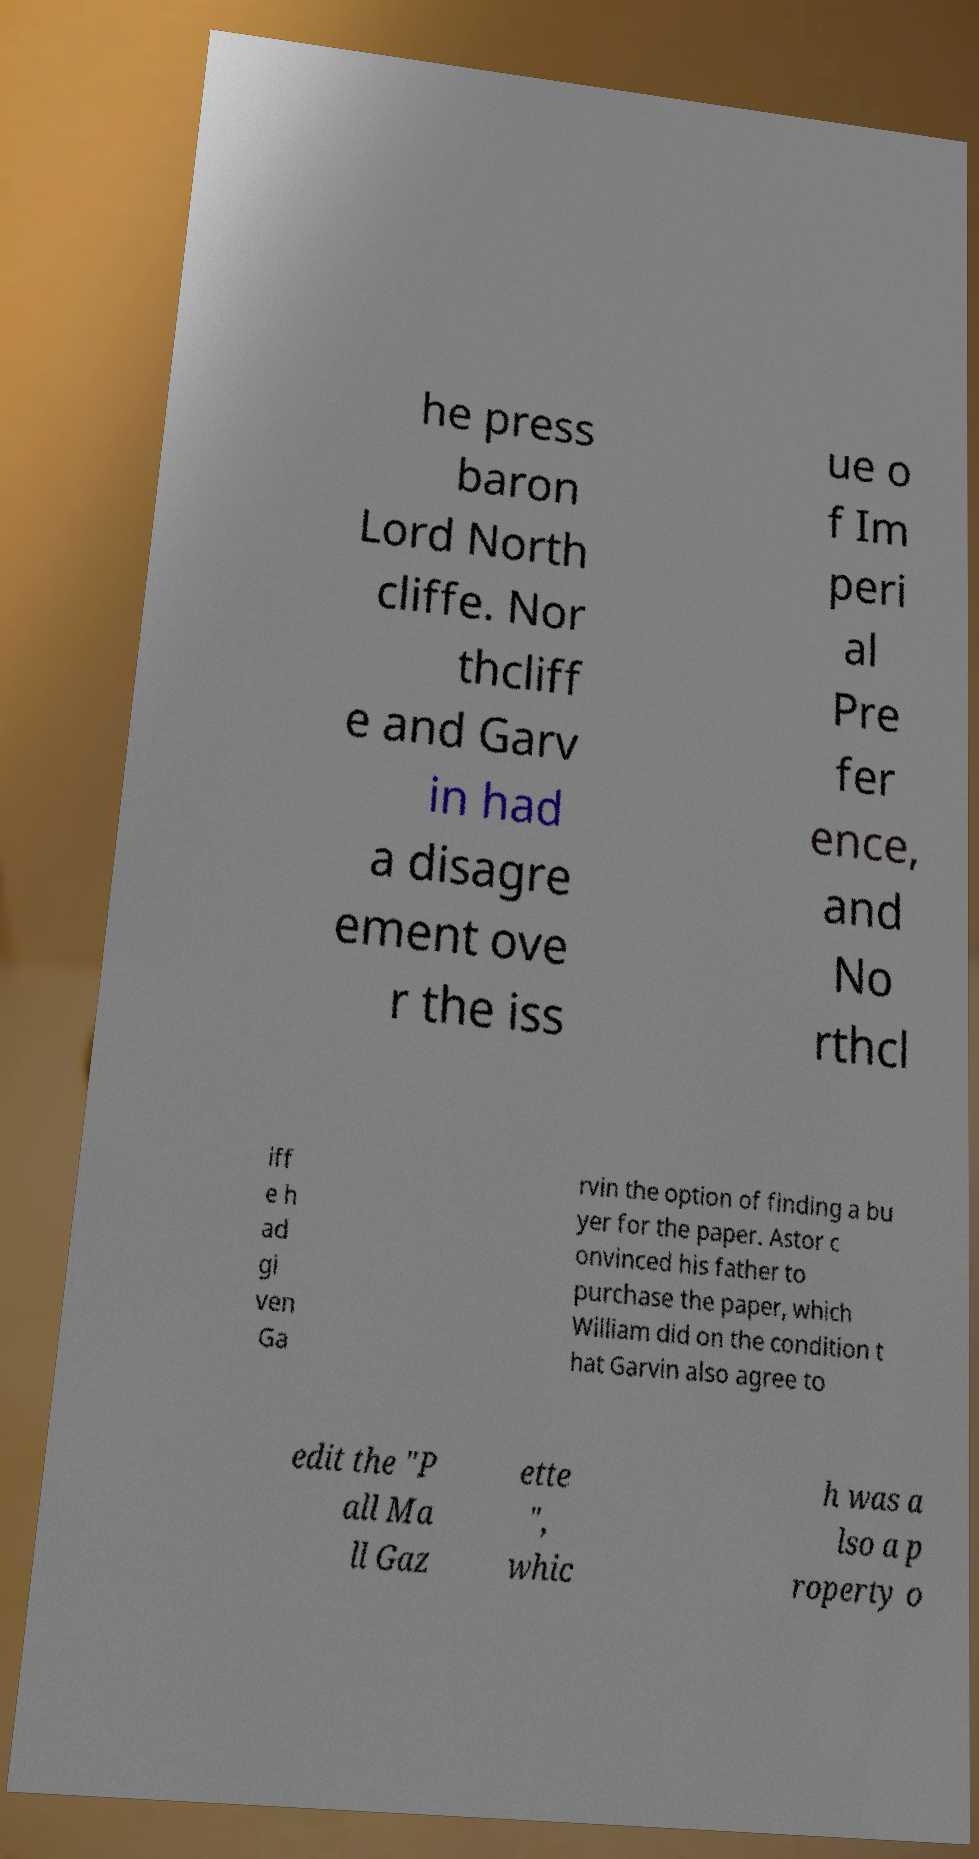Please identify and transcribe the text found in this image. he press baron Lord North cliffe. Nor thcliff e and Garv in had a disagre ement ove r the iss ue o f Im peri al Pre fer ence, and No rthcl iff e h ad gi ven Ga rvin the option of finding a bu yer for the paper. Astor c onvinced his father to purchase the paper, which William did on the condition t hat Garvin also agree to edit the "P all Ma ll Gaz ette ", whic h was a lso a p roperty o 